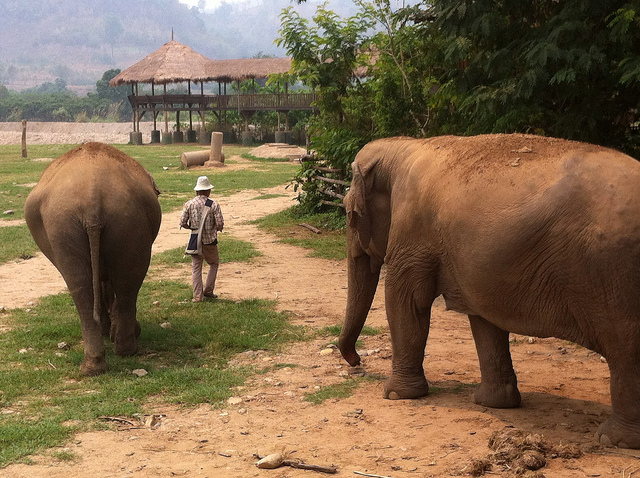How many elephants are following after the man wearing a white hat? There are two elephants following behind the man wearing a white hat. The man leads the way with a confident stride, suggesting a familiarity with his large companions. 